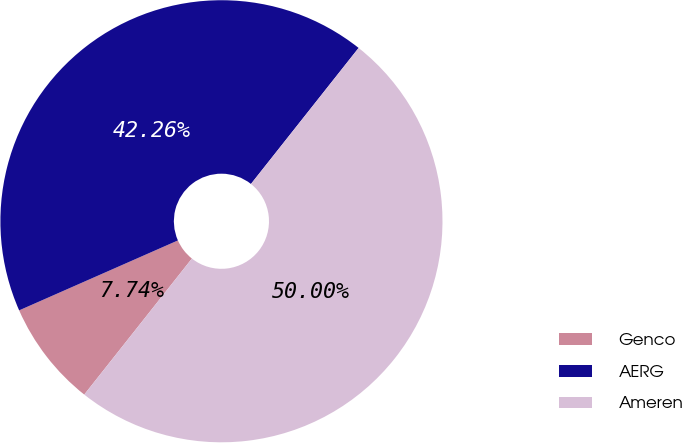Convert chart. <chart><loc_0><loc_0><loc_500><loc_500><pie_chart><fcel>Genco<fcel>AERG<fcel>Ameren<nl><fcel>7.74%<fcel>42.26%<fcel>50.0%<nl></chart> 